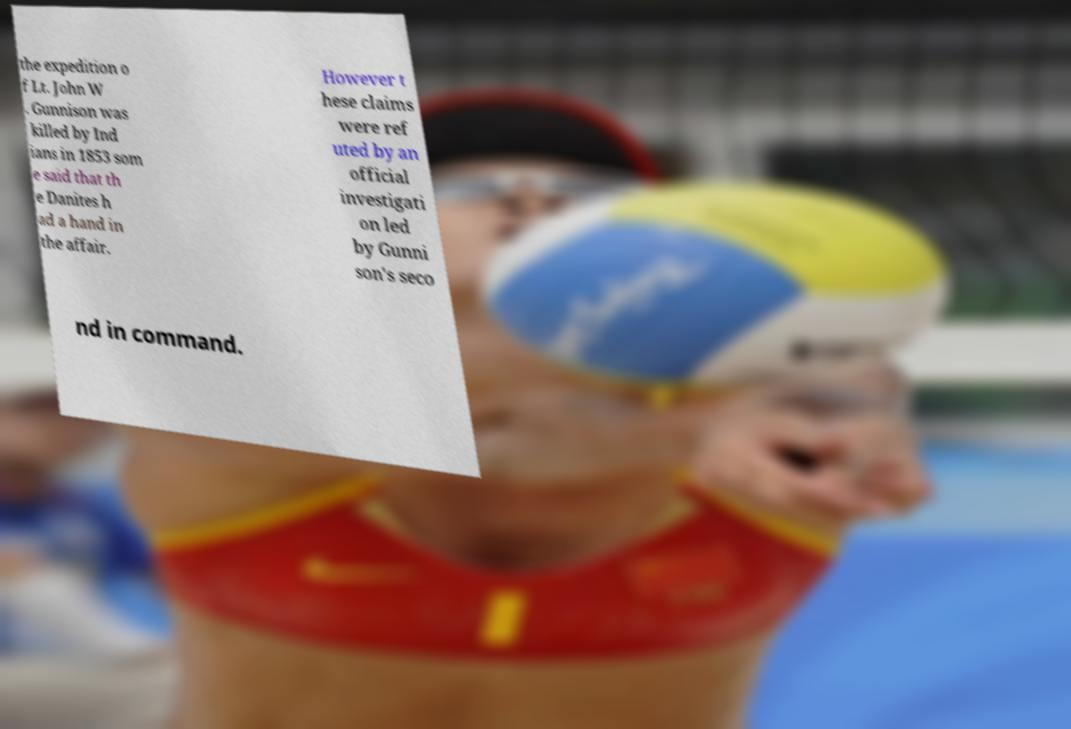Please identify and transcribe the text found in this image. the expedition o f Lt. John W . Gunnison was killed by Ind ians in 1853 som e said that th e Danites h ad a hand in the affair. However t hese claims were ref uted by an official investigati on led by Gunni son's seco nd in command. 